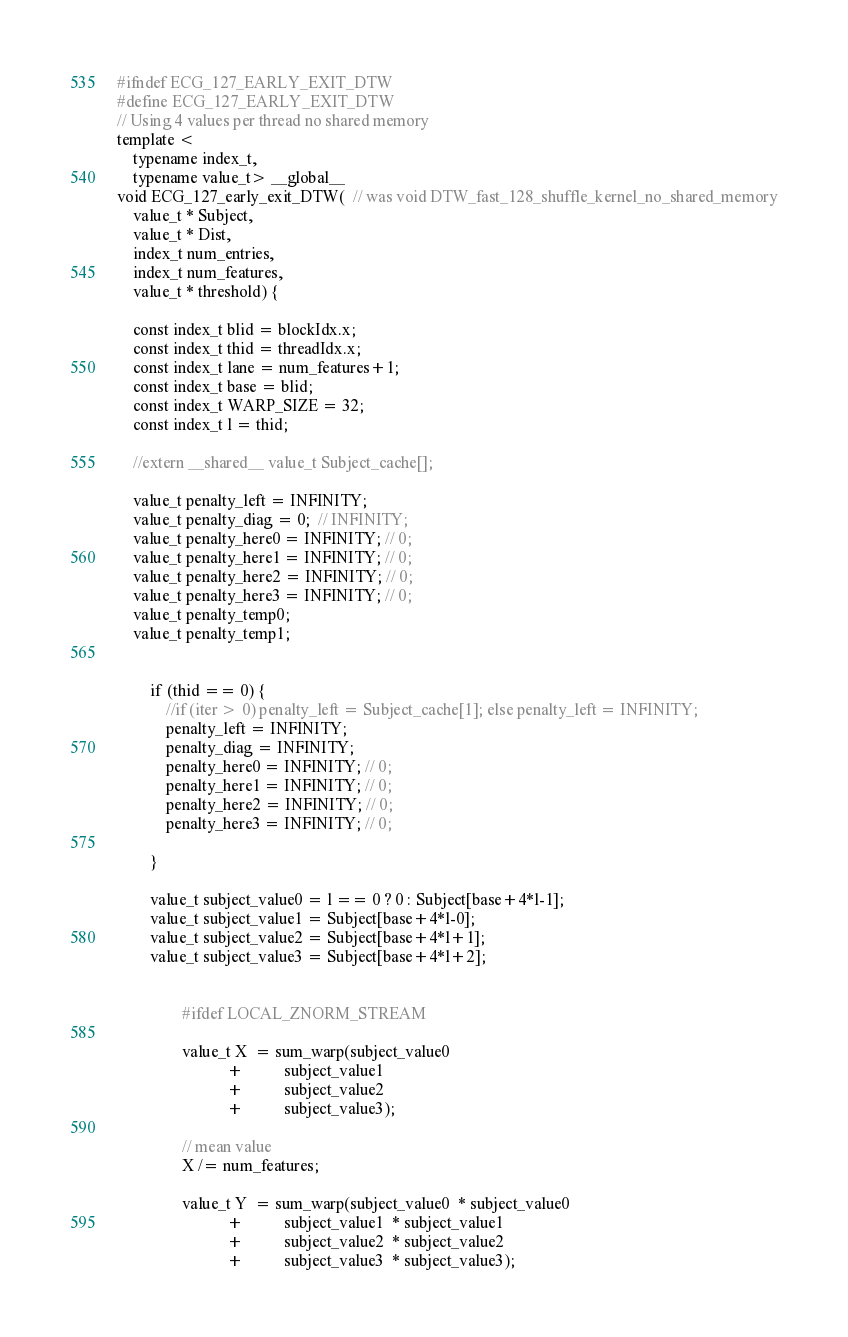<code> <loc_0><loc_0><loc_500><loc_500><_Cuda_>#ifndef ECG_127_EARLY_EXIT_DTW
#define ECG_127_EARLY_EXIT_DTW
// Using 4 values per thread no shared memory
template <
    typename index_t,
    typename value_t> __global__
void ECG_127_early_exit_DTW(  // was void DTW_fast_128_shuffle_kernel_no_shared_memory
    value_t * Subject,
    value_t * Dist,
    index_t num_entries,
    index_t num_features,
    value_t * threshold) {

    const index_t blid = blockIdx.x;
    const index_t thid = threadIdx.x;
    const index_t lane = num_features+1;
    const index_t base = blid;
    const index_t WARP_SIZE = 32;
    const index_t l = thid;

    //extern __shared__ value_t Subject_cache[];

    value_t penalty_left = INFINITY;
    value_t penalty_diag = 0;  // INFINITY;
    value_t penalty_here0 = INFINITY; // 0;
    value_t penalty_here1 = INFINITY; // 0;
    value_t penalty_here2 = INFINITY; // 0;
    value_t penalty_here3 = INFINITY; // 0;
    value_t penalty_temp0;
    value_t penalty_temp1;


        if (thid == 0) {
            //if (iter > 0) penalty_left = Subject_cache[1]; else penalty_left = INFINITY;
            penalty_left = INFINITY;
            penalty_diag = INFINITY;
            penalty_here0 = INFINITY; // 0;
            penalty_here1 = INFINITY; // 0;
            penalty_here2 = INFINITY; // 0;
            penalty_here3 = INFINITY; // 0;

        }

        value_t subject_value0 = l == 0 ? 0 : Subject[base+4*l-1];
        value_t subject_value1 = Subject[base+4*l-0];
        value_t subject_value2 = Subject[base+4*l+1];
        value_t subject_value3 = Subject[base+4*l+2];


                #ifdef LOCAL_ZNORM_STREAM

                value_t X  = sum_warp(subject_value0
                           +          subject_value1
                           +          subject_value2
                           +          subject_value3);

                // mean value
                X /= num_features;

                value_t Y  = sum_warp(subject_value0  * subject_value0
                           +          subject_value1  * subject_value1
                           +          subject_value2  * subject_value2
                           +          subject_value3  * subject_value3);
</code> 